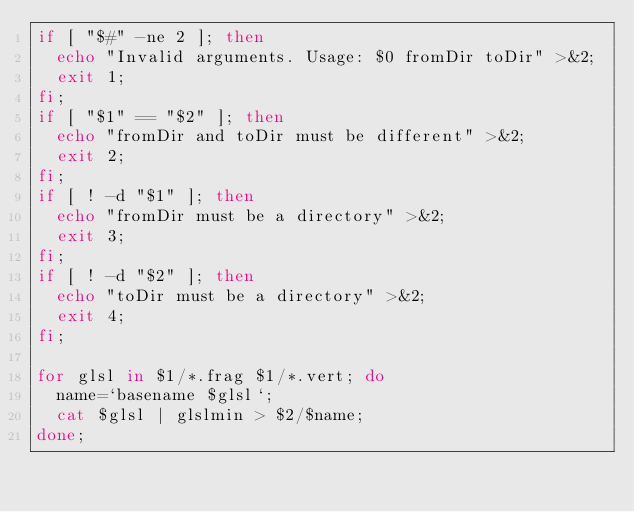Convert code to text. <code><loc_0><loc_0><loc_500><loc_500><_Bash_>if [ "$#" -ne 2 ]; then
  echo "Invalid arguments. Usage: $0 fromDir toDir" >&2;
  exit 1;
fi;
if [ "$1" == "$2" ]; then
  echo "fromDir and toDir must be different" >&2;
  exit 2;
fi;
if [ ! -d "$1" ]; then
  echo "fromDir must be a directory" >&2;
  exit 3;
fi;
if [ ! -d "$2" ]; then
  echo "toDir must be a directory" >&2;
  exit 4;
fi;

for glsl in $1/*.frag $1/*.vert; do
  name=`basename $glsl`;
  cat $glsl | glslmin > $2/$name;
done;
</code> 